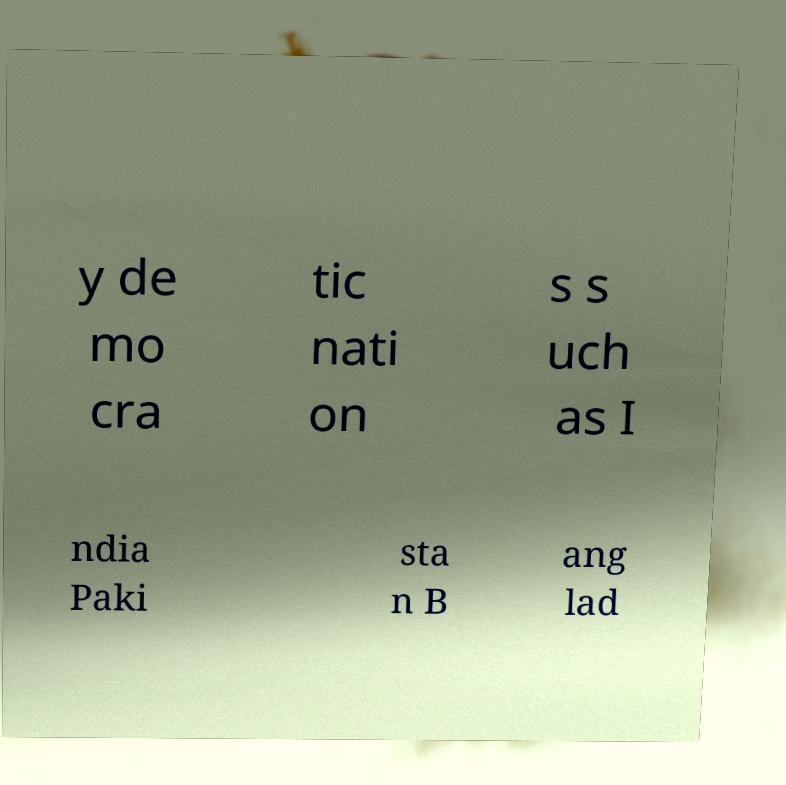For documentation purposes, I need the text within this image transcribed. Could you provide that? y de mo cra tic nati on s s uch as I ndia Paki sta n B ang lad 